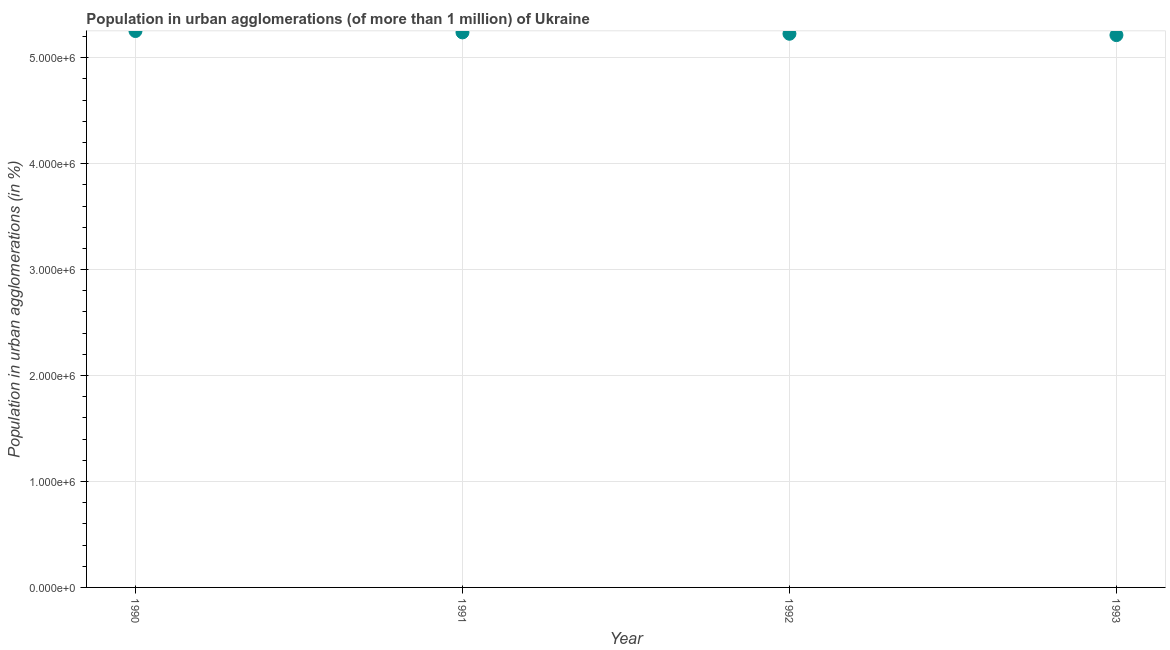What is the population in urban agglomerations in 1993?
Ensure brevity in your answer.  5.21e+06. Across all years, what is the maximum population in urban agglomerations?
Keep it short and to the point. 5.25e+06. Across all years, what is the minimum population in urban agglomerations?
Provide a succinct answer. 5.21e+06. What is the sum of the population in urban agglomerations?
Give a very brief answer. 2.09e+07. What is the difference between the population in urban agglomerations in 1991 and 1992?
Provide a succinct answer. 1.28e+04. What is the average population in urban agglomerations per year?
Your answer should be very brief. 5.23e+06. What is the median population in urban agglomerations?
Provide a succinct answer. 5.23e+06. In how many years, is the population in urban agglomerations greater than 1800000 %?
Give a very brief answer. 4. Do a majority of the years between 1991 and 1992 (inclusive) have population in urban agglomerations greater than 1800000 %?
Ensure brevity in your answer.  Yes. What is the ratio of the population in urban agglomerations in 1991 to that in 1993?
Your answer should be very brief. 1. Is the population in urban agglomerations in 1992 less than that in 1993?
Your answer should be compact. No. Is the difference between the population in urban agglomerations in 1991 and 1993 greater than the difference between any two years?
Give a very brief answer. No. What is the difference between the highest and the second highest population in urban agglomerations?
Your answer should be very brief. 1.29e+04. Is the sum of the population in urban agglomerations in 1992 and 1993 greater than the maximum population in urban agglomerations across all years?
Provide a succinct answer. Yes. What is the difference between the highest and the lowest population in urban agglomerations?
Offer a very short reply. 3.85e+04. In how many years, is the population in urban agglomerations greater than the average population in urban agglomerations taken over all years?
Offer a very short reply. 2. What is the difference between two consecutive major ticks on the Y-axis?
Your answer should be very brief. 1.00e+06. Are the values on the major ticks of Y-axis written in scientific E-notation?
Provide a succinct answer. Yes. Does the graph contain grids?
Provide a short and direct response. Yes. What is the title of the graph?
Offer a terse response. Population in urban agglomerations (of more than 1 million) of Ukraine. What is the label or title of the Y-axis?
Keep it short and to the point. Population in urban agglomerations (in %). What is the Population in urban agglomerations (in %) in 1990?
Give a very brief answer. 5.25e+06. What is the Population in urban agglomerations (in %) in 1991?
Your response must be concise. 5.24e+06. What is the Population in urban agglomerations (in %) in 1992?
Your answer should be very brief. 5.23e+06. What is the Population in urban agglomerations (in %) in 1993?
Give a very brief answer. 5.21e+06. What is the difference between the Population in urban agglomerations (in %) in 1990 and 1991?
Give a very brief answer. 1.29e+04. What is the difference between the Population in urban agglomerations (in %) in 1990 and 1992?
Make the answer very short. 2.58e+04. What is the difference between the Population in urban agglomerations (in %) in 1990 and 1993?
Make the answer very short. 3.85e+04. What is the difference between the Population in urban agglomerations (in %) in 1991 and 1992?
Keep it short and to the point. 1.28e+04. What is the difference between the Population in urban agglomerations (in %) in 1991 and 1993?
Your answer should be very brief. 2.55e+04. What is the difference between the Population in urban agglomerations (in %) in 1992 and 1993?
Provide a succinct answer. 1.27e+04. What is the ratio of the Population in urban agglomerations (in %) in 1990 to that in 1993?
Your answer should be very brief. 1.01. What is the ratio of the Population in urban agglomerations (in %) in 1991 to that in 1993?
Offer a terse response. 1. What is the ratio of the Population in urban agglomerations (in %) in 1992 to that in 1993?
Provide a succinct answer. 1. 